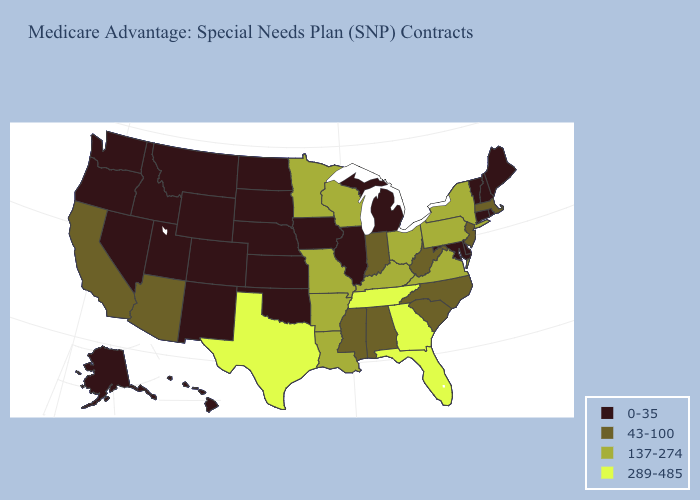What is the value of California?
Keep it brief. 43-100. What is the value of Wisconsin?
Quick response, please. 137-274. Does the first symbol in the legend represent the smallest category?
Keep it brief. Yes. What is the highest value in states that border Connecticut?
Write a very short answer. 137-274. What is the value of Illinois?
Concise answer only. 0-35. What is the value of New Jersey?
Concise answer only. 43-100. Does Oklahoma have the lowest value in the USA?
Concise answer only. Yes. Does Arizona have the lowest value in the West?
Keep it brief. No. Among the states that border Florida , which have the highest value?
Write a very short answer. Georgia. Does California have a lower value than Wyoming?
Give a very brief answer. No. Which states hav the highest value in the West?
Short answer required. Arizona, California. Does Virginia have the highest value in the USA?
Write a very short answer. No. Which states hav the highest value in the West?
Keep it brief. Arizona, California. Which states have the highest value in the USA?
Keep it brief. Florida, Georgia, Tennessee, Texas. Among the states that border Missouri , which have the lowest value?
Write a very short answer. Iowa, Illinois, Kansas, Nebraska, Oklahoma. 